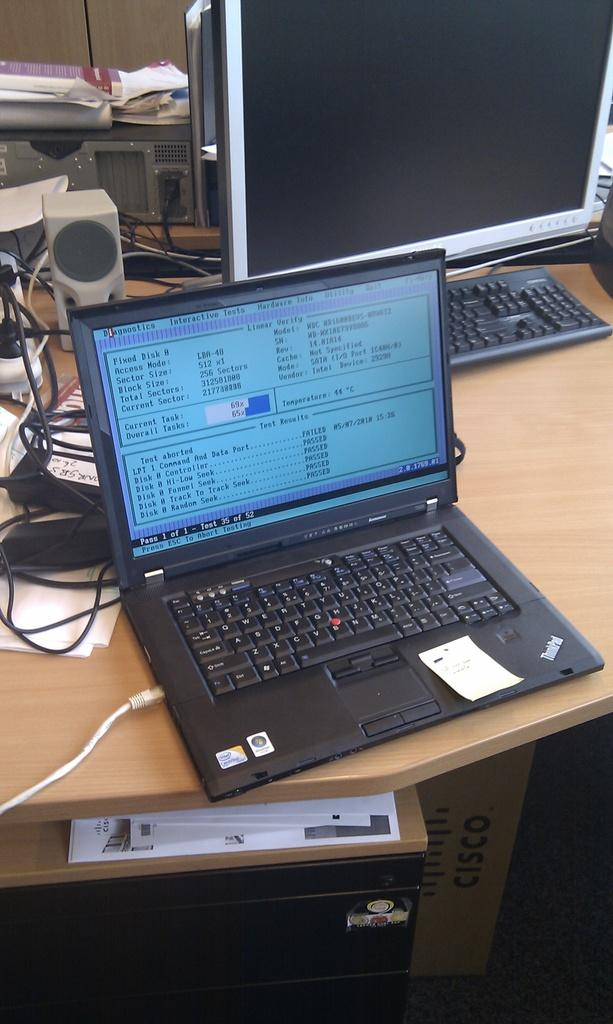<image>
Describe the image concisely. Lenovo laptop monitor showing Fixed Disk 0 on the top left. 